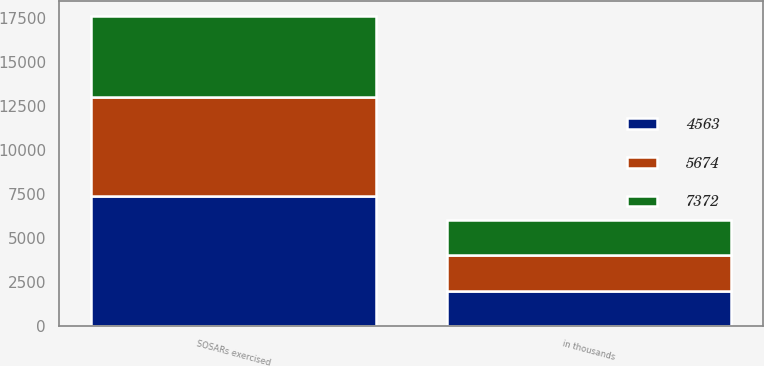<chart> <loc_0><loc_0><loc_500><loc_500><stacked_bar_chart><ecel><fcel>in thousands<fcel>SOSARs exercised<nl><fcel>4563<fcel>2014<fcel>7372<nl><fcel>7372<fcel>2013<fcel>4563<nl><fcel>5674<fcel>2012<fcel>5674<nl></chart> 